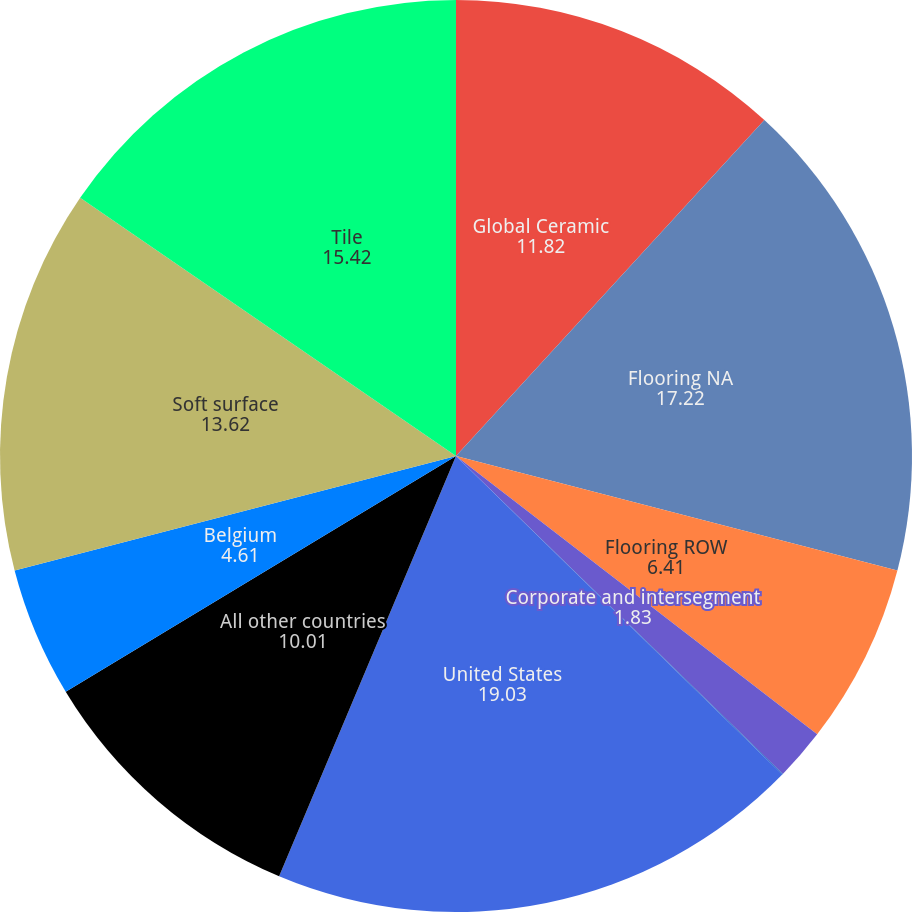Convert chart to OTSL. <chart><loc_0><loc_0><loc_500><loc_500><pie_chart><fcel>Global Ceramic<fcel>Flooring NA<fcel>Flooring ROW<fcel>Corporate and intersegment<fcel>Corporate<fcel>United States<fcel>All other countries<fcel>Belgium<fcel>Soft surface<fcel>Tile<nl><fcel>11.82%<fcel>17.22%<fcel>6.41%<fcel>1.83%<fcel>0.03%<fcel>19.03%<fcel>10.01%<fcel>4.61%<fcel>13.62%<fcel>15.42%<nl></chart> 